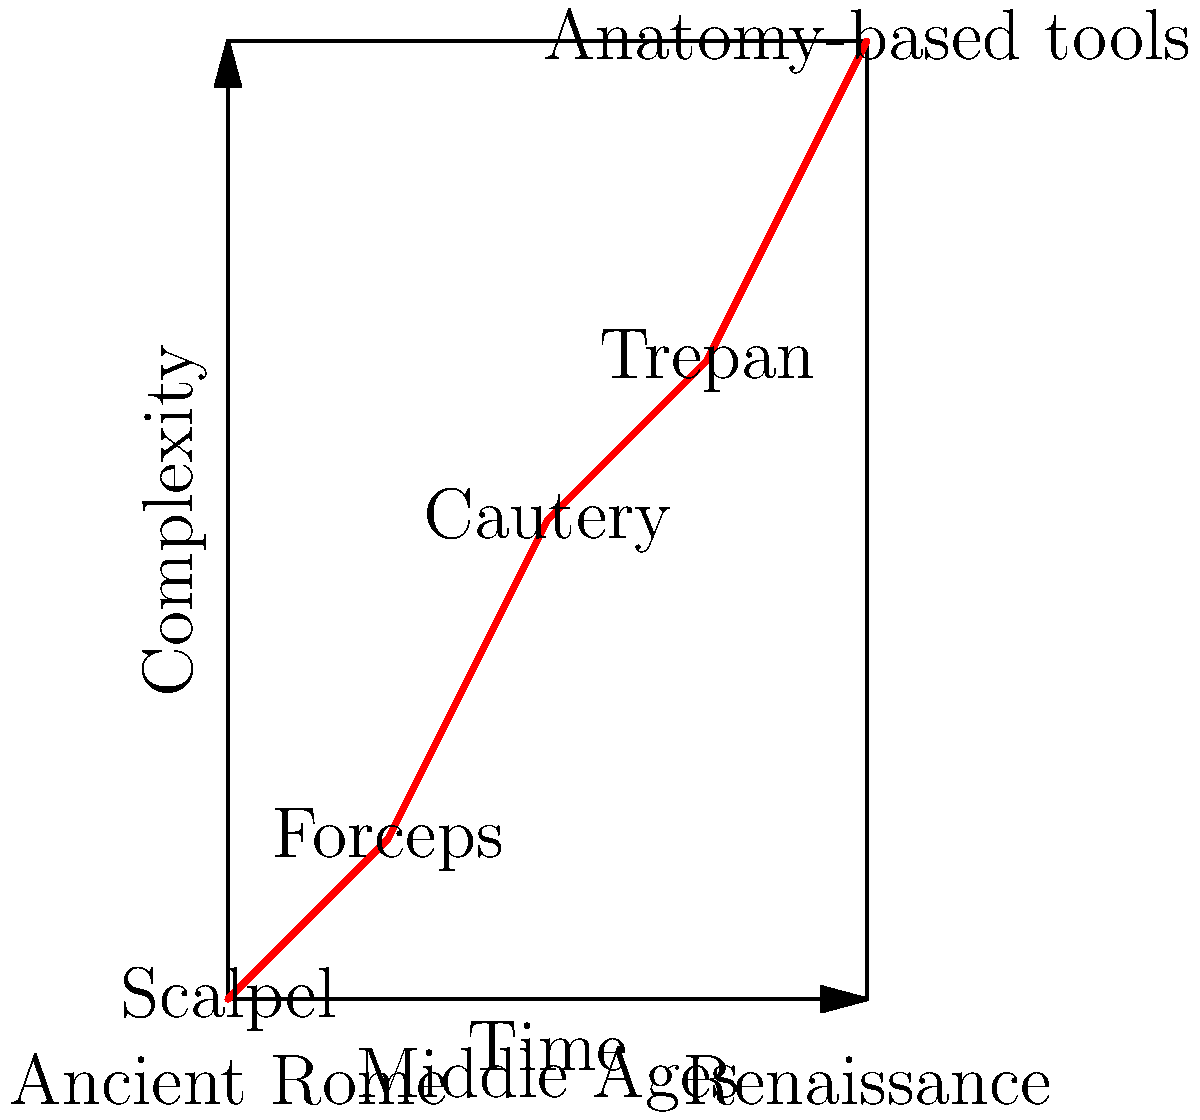Based on the graph showing the evolution of surgical instruments in Italy from Ancient Roman times to the Renaissance, which period saw the most significant increase in the complexity of surgical tools? To determine the period with the most significant increase in surgical tool complexity, we need to analyze the slope of the line between each period:

1. Ancient Rome to Early Middle Ages:
   Slope = (1 - 0) / (1 - 0) = 1

2. Early Middle Ages to High Middle Ages:
   Slope = (3 - 1) / (2 - 1) = 2

3. High Middle Ages to Late Middle Ages:
   Slope = (4 - 3) / (3 - 2) = 1

4. Late Middle Ages to Renaissance:
   Slope = (6 - 4) / (4 - 3) = 2

The steeper the slope, the more rapid the increase in complexity. We can see that the slopes between Early Middle Ages to High Middle Ages and Late Middle Ages to Renaissance are both 2, which is the highest.

However, the Renaissance period shows a higher absolute increase (from 4 to 6) compared to the High Middle Ages (from 1 to 3). This suggests that while both periods saw significant advancements, the Renaissance period experienced a more substantial overall increase in the complexity of surgical instruments.
Answer: Renaissance 